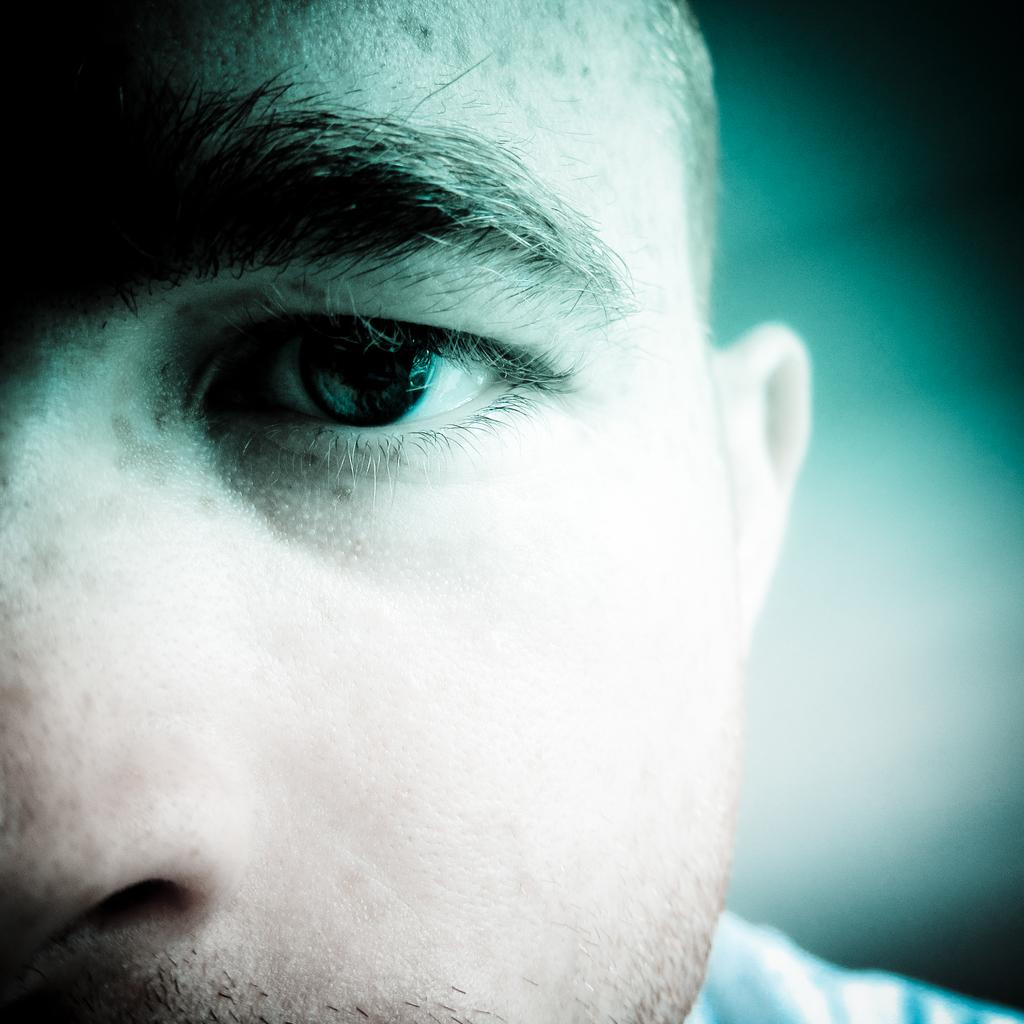What is the main subject of the image? There is a man's face in the image. Can you describe the background of the image? The background of the image is blurry. How many horses are visible in the image? There are no horses present in the image; it features a man's face with a blurry background. Is there any blood visible on the man's face in the image? There is no blood visible on the man's face in the image. 